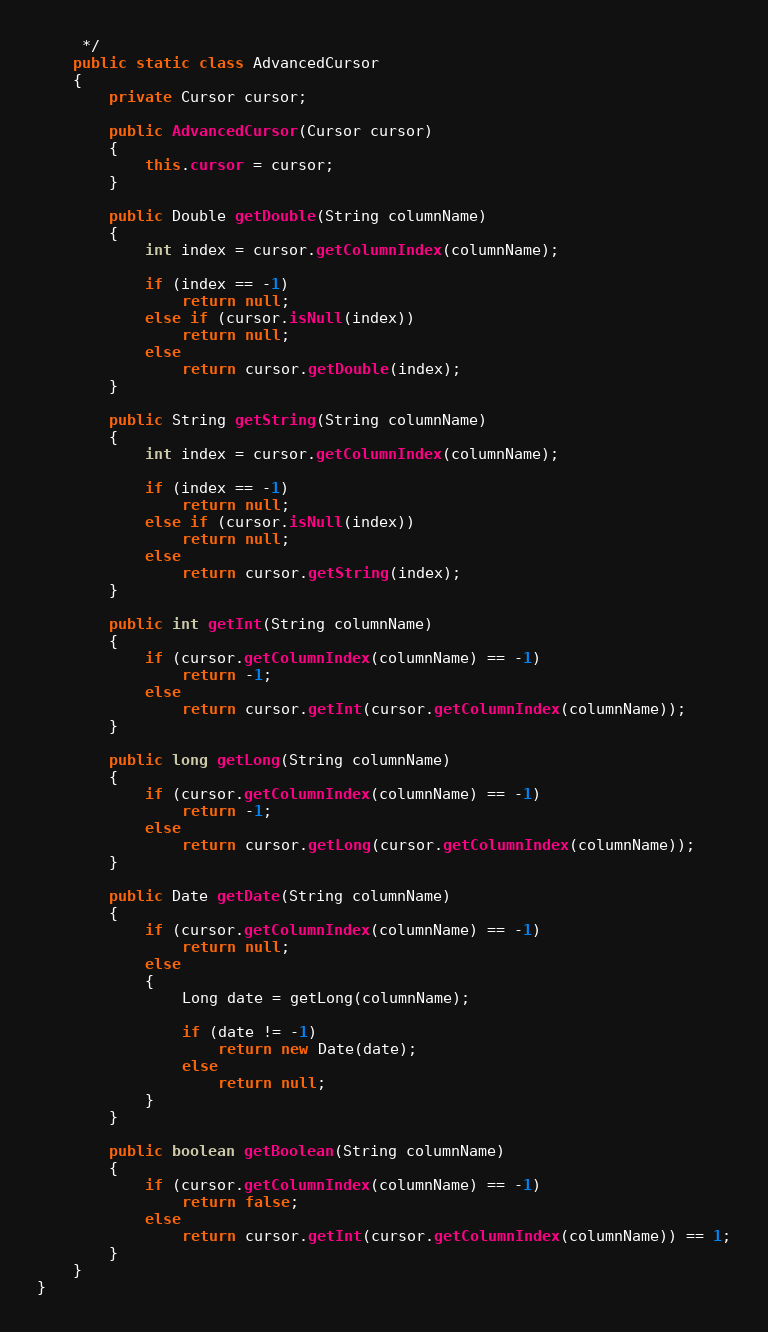<code> <loc_0><loc_0><loc_500><loc_500><_Java_>	 */
	public static class AdvancedCursor
	{
		private Cursor cursor;

		public AdvancedCursor(Cursor cursor)
		{
			this.cursor = cursor;
		}

		public Double getDouble(String columnName)
		{
			int index = cursor.getColumnIndex(columnName);

			if (index == -1)
				return null;
			else if (cursor.isNull(index))
				return null;
			else
				return cursor.getDouble(index);
		}

		public String getString(String columnName)
		{
			int index = cursor.getColumnIndex(columnName);

			if (index == -1)
				return null;
			else if (cursor.isNull(index))
				return null;
			else
				return cursor.getString(index);
		}

		public int getInt(String columnName)
		{
			if (cursor.getColumnIndex(columnName) == -1)
				return -1;
			else
				return cursor.getInt(cursor.getColumnIndex(columnName));
		}

		public long getLong(String columnName)
		{
			if (cursor.getColumnIndex(columnName) == -1)
				return -1;
			else
				return cursor.getLong(cursor.getColumnIndex(columnName));
		}

		public Date getDate(String columnName)
		{
			if (cursor.getColumnIndex(columnName) == -1)
				return null;
			else
			{
				Long date = getLong(columnName);

				if (date != -1)
					return new Date(date);
				else
					return null;
			}
		}

		public boolean getBoolean(String columnName)
		{
			if (cursor.getColumnIndex(columnName) == -1)
				return false;
			else
				return cursor.getInt(cursor.getColumnIndex(columnName)) == 1;
		}
	}
}
</code> 